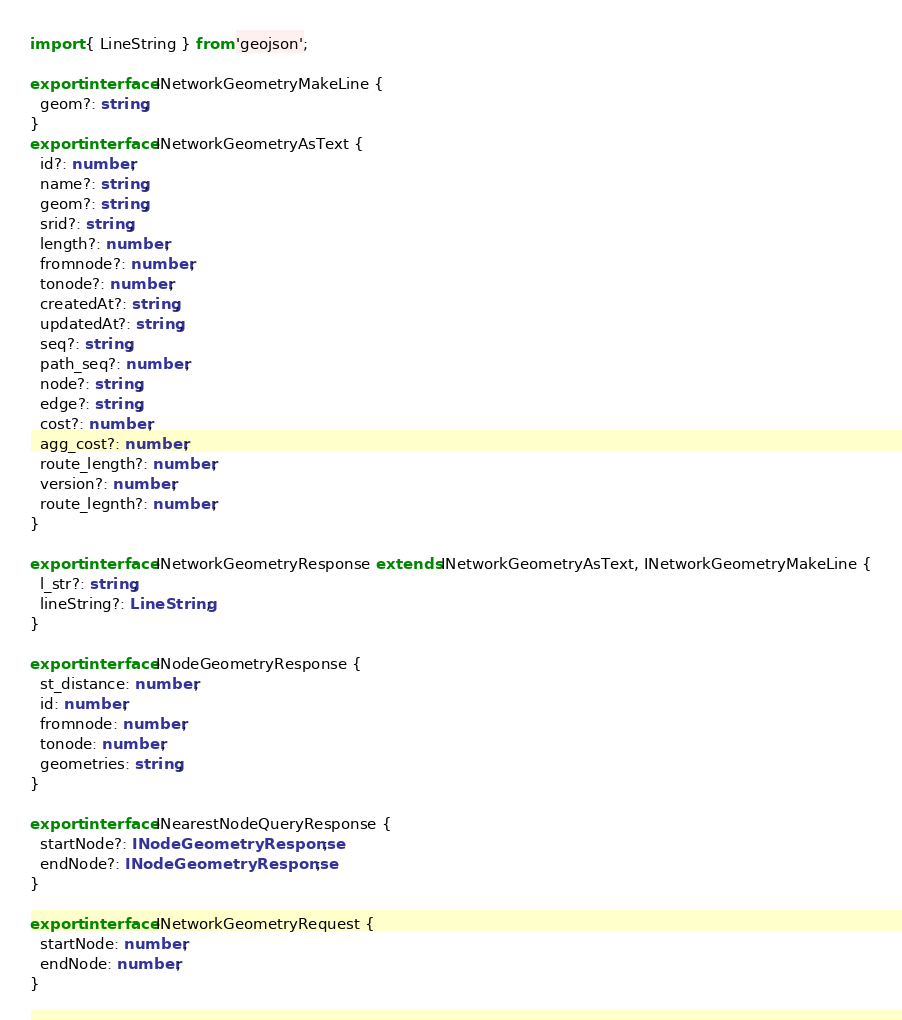<code> <loc_0><loc_0><loc_500><loc_500><_TypeScript_>import { LineString } from 'geojson';

export interface INetworkGeometryMakeLine {
  geom?: string;
}
export interface INetworkGeometryAsText {
  id?: number;
  name?: string;
  geom?: string;
  srid?: string;
  length?: number;
  fromnode?: number;
  tonode?: number;
  createdAt?: string;
  updatedAt?: string;
  seq?: string;
  path_seq?: number;
  node?: string;
  edge?: string;
  cost?: number;
  agg_cost?: number;
  route_length?: number;
  version?: number;
  route_legnth?: number;
}

export interface INetworkGeometryResponse extends INetworkGeometryAsText, INetworkGeometryMakeLine {
  l_str?: string;
  lineString?: LineString;
}

export interface INodeGeometryResponse {
  st_distance: number;
  id: number;
  fromnode: number;
  tonode: number;
  geometries: string;
}

export interface INearestNodeQueryResponse {
  startNode?: INodeGeometryResponse;
  endNode?: INodeGeometryResponse;
}

export interface INetworkGeometryRequest {
  startNode: number;
  endNode: number;
}
</code> 